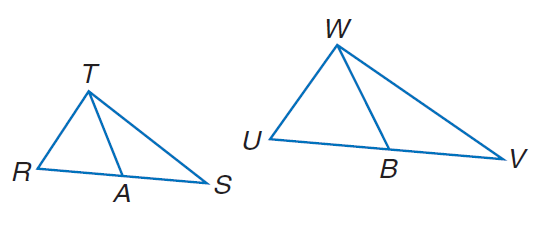Answer the mathemtical geometry problem and directly provide the correct option letter.
Question: Find U B if \triangle R S T \sim \triangle U V W, T A and W B are medians, T A = 8, R A = 3, W B = 3 x - 6, and U B = x + 2.
Choices: A: 24 B: 28 C: 32 D: 36 D 